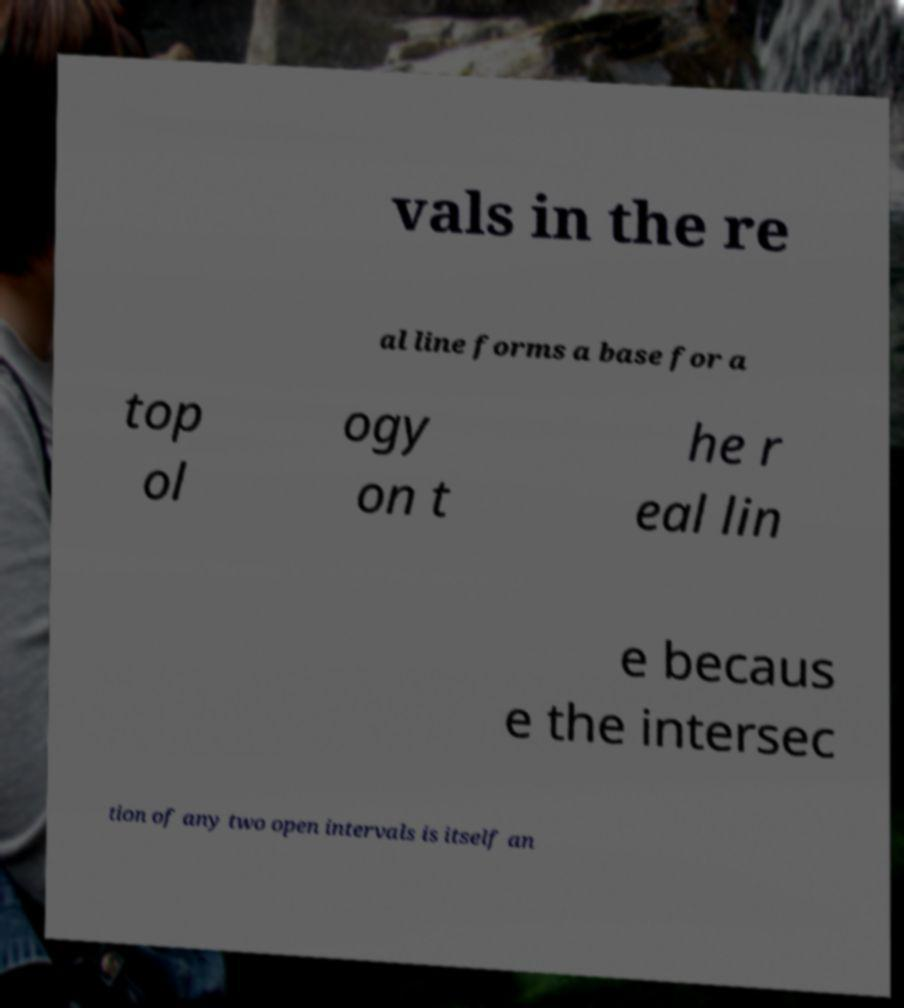Could you extract and type out the text from this image? vals in the re al line forms a base for a top ol ogy on t he r eal lin e becaus e the intersec tion of any two open intervals is itself an 